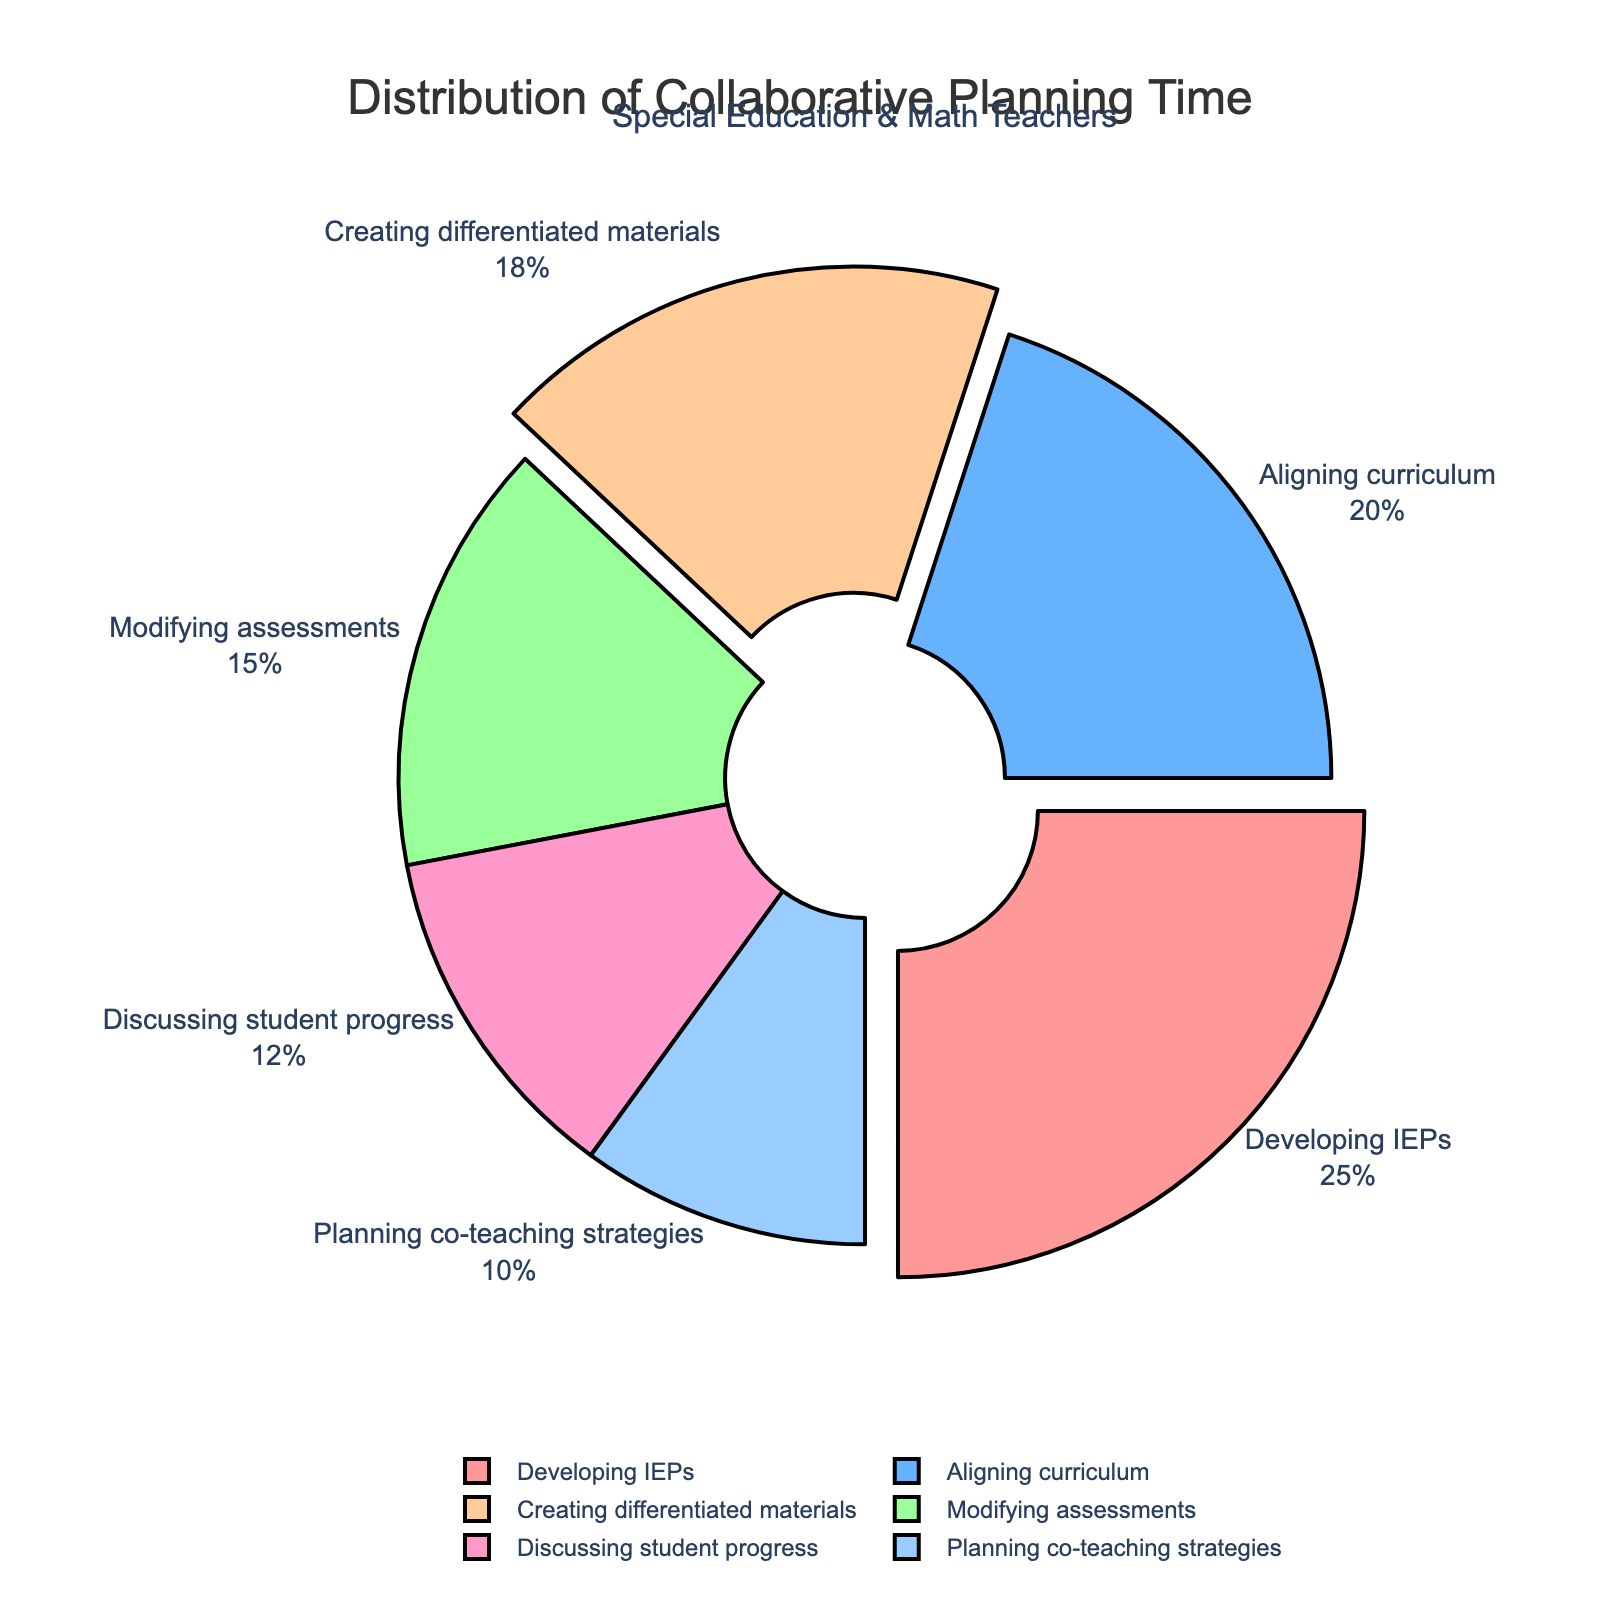What's the largest slice in the pie chart? The largest slice represents the activity with the highest percentage of collaborative planning time. From the figure, the "Developing IEPs" slice is the largest, accounting for 25%.
Answer: Developing IEPs Which activity takes up more time, "Aligning curriculum" or "Planning co-teaching strategies"? To compare, look at the percentages for each activity. The figure shows "Aligning curriculum" at 20% and "Planning co-teaching strategies" at 10%.
Answer: Aligning curriculum What's the combined percentage for "Creating differentiated materials" and "Discussing student progress"? Add the percentages for both activities: Creating differentiated materials (18%) and Discussing student progress (12%). So, 18% + 12% = 30%.
Answer: 30% How much more time is spent on "Modifying assessments" compared to "Planning co-teaching strategies"? To find the difference, subtract the percentage for "Planning co-teaching strategies" (10%) from "Modifying assessments" (15%). So, 15% - 10% = 5%.
Answer: 5% What is the average time spent on the three activities with the smallest percentages? Identify the three activities with the smallest percentages: Discussing student progress (12%), Planning co-teaching strategies (10%), and Modifying assessments (15%). Calculate the average: (12% + 10% + 15%) / 3 = 12.33%.
Answer: 12.33% Which activity has the pink color slice? The pie chart uses different colors for each slice. From the visual information, the pink-colored slice corresponds to the activity "Developing IEPs."
Answer: Developing IEPs How much more time is spent on "Creating differentiated materials" than on "Discussing student progress"? Subtract the percentage of "Discussing student progress" (12%) from "Creating differentiated materials" (18%). So, 18% - 12% = 6%.
Answer: 6% What is the median value of the distribution percentages? List all the activity percentages in ascending order: 10%, 12%, 15%, 18%, 20%, 25%. The median will be the average of the third and fourth values: (15% + 18%) / 2 = 16.5%.
Answer: 16.5% If you combined the time for "Developing IEPs" and "Aligning curriculum," would that be more than half of the total planning time? Add the percentages for the two activities: Developing IEPs (25%) + Aligning curriculum (20%). The sum is 45%, which is less than 50%.
Answer: No 